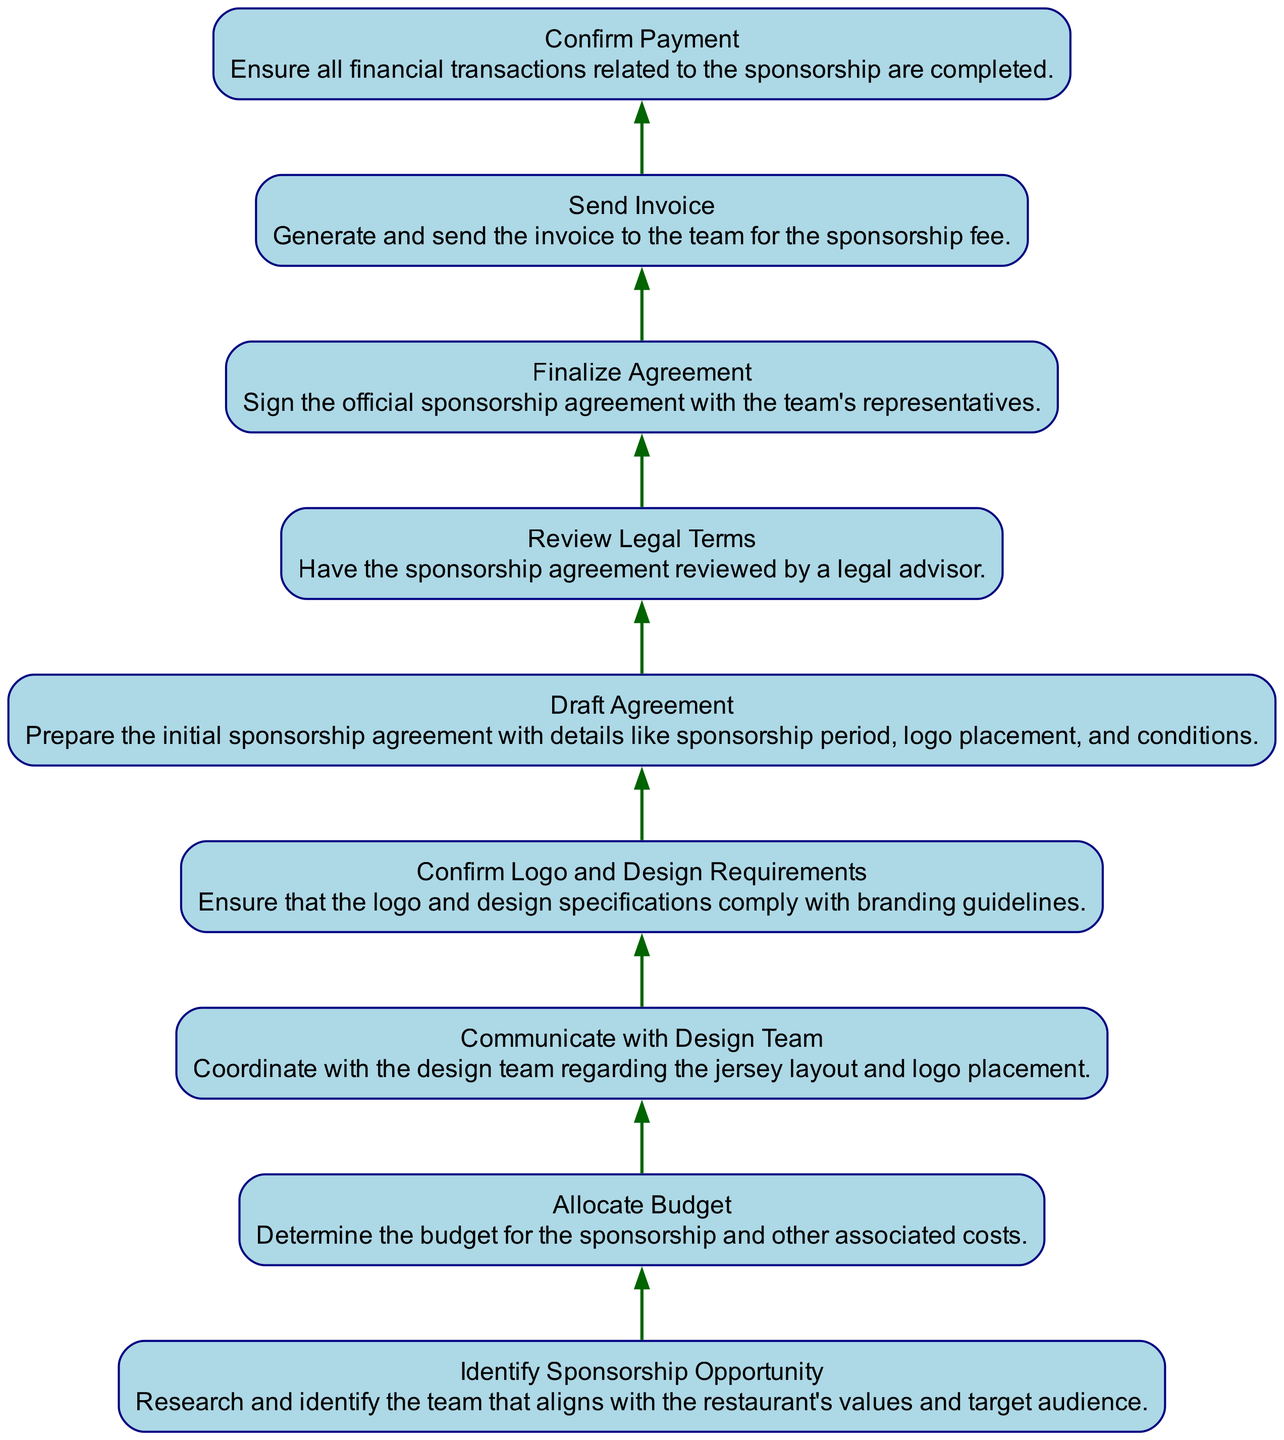What's the first step in managing sponsorship agreements? The first step in managing sponsorship agreements is to identify the sponsorship opportunity. This is indicated as the starting node in the diagram without any dependencies before it.
Answer: Identify Sponsorship Opportunity What is the last step in the process? The last step in the process is to confirm payment. This is shown as the final node in the flowchart.
Answer: Confirm Payment How many nodes are in the diagram? The diagram contains nine nodes. By counting each unique step from the start to the end, we arrive at this total.
Answer: Nine Which step depends on confirming logo and design requirements? The step that depends on confirming logo and design requirements is drafting the agreement. This is shown in the dependencies leading from "Confirm Logo and Design Requirements" to "Draft Agreement."
Answer: Draft Agreement What is the direct dependency of sending the invoice? The direct dependency of sending the invoice is finalizing the agreement. The flow shows that the invoice can only be sent after the agreement is finalized.
Answer: Finalize Agreement Which nodes are dependent on communicating with the design team? The nodes that are dependent on communicating with the design team are drafting the agreement and confirming logo and design requirements. They follow in the flow after the design team communication.
Answer: Draft Agreement, Confirm Logo and Design Requirements What is required before finalizing the agreement? Before finalizing the agreement, reviewing legal terms is required. This is illustrated as a prerequisite step that must occur first.
Answer: Review Legal Terms How does the budget allocation relate to identifying sponsorship opportunities? Budget allocation is dependent on identifying sponsorship opportunities. After identifying a suitable team, the budget can be allocated based on the resources available for the sponsorship.
Answer: Allocate Budget What is the relationship between sending the invoice and confirming payment? The relationship between sending the invoice and confirming payment is that confirming payment is dependent on having sent the invoice first. The flow indicates that payment confirmation cannot happen without the invoice.
Answer: Send Invoice 